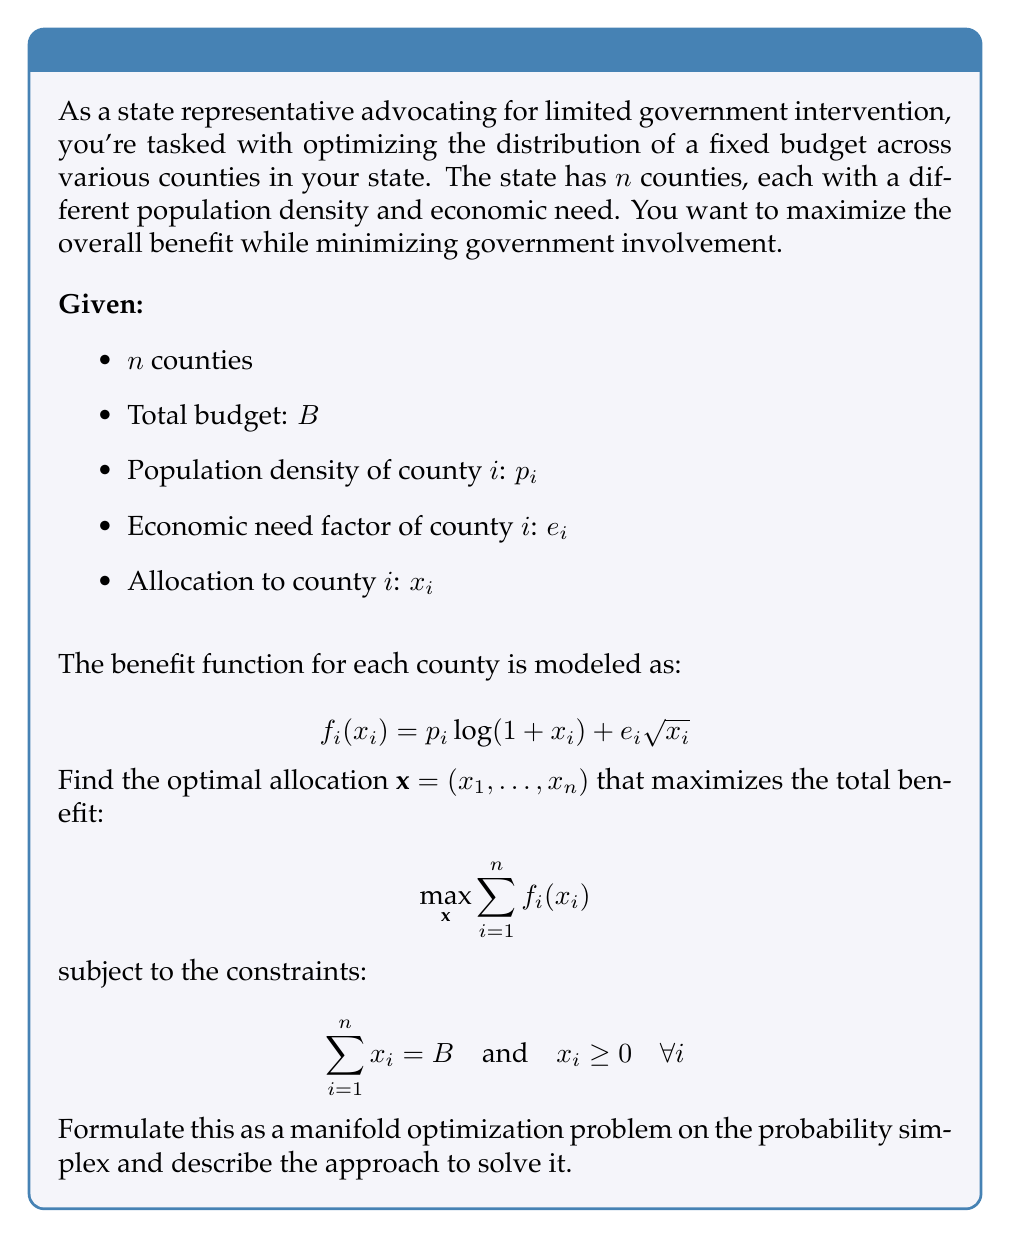Teach me how to tackle this problem. To solve this problem using manifold optimization, we can follow these steps:

1) First, we recognize that the constraint $\sum_{i=1}^n x_i = B$ with $x_i \geq 0$ defines a scaled probability simplex. We can transform our variables to work on the standard probability simplex by setting $y_i = x_i / B$. This gives us:

   $$ \max_{\mathbf{y}} \sum_{i=1}^n p_i \log(1 + By_i) + e_i \sqrt{By_i} $$
   
   subject to $\sum_{i=1}^n y_i = 1$ and $y_i \geq 0$.

2) The standard probability simplex is a manifold, specifically a $(n-1)$-dimensional manifold embedded in $\mathbb{R}^n$.

3) We can use the Riemannian gradient descent method on this manifold. The Riemannian gradient is the projection of the Euclidean gradient onto the tangent space of the manifold.

4) The Euclidean gradient for each $y_i$ is:

   $$ \frac{\partial f}{\partial y_i} = \frac{Bp_i}{1 + By_i} + \frac{Be_i}{2\sqrt{By_i}} $$

5) The projection onto the tangent space of the probability simplex is given by:

   $$ \text{Proj}_T(g) = g - (\mathbf{1}^T g)\mathbf{1} $$

   where $g$ is the Euclidean gradient and $\mathbf{1}$ is the vector of all ones.

6) The Riemannian gradient descent update step is:

   $$ \mathbf{y}^{(k+1)} = \text{Retr}_{\mathbf{y}^{(k)}}(-\alpha \text{Proj}_T(g)) $$

   where $\alpha$ is the step size and Retr is the retraction operation that maps a point in the tangent space back to the manifold.

7) For the probability simplex, a simple retraction is the projection onto the simplex, which can be done efficiently using algorithms like the one proposed by Wang and Carreira-Perpinán (2013).

8) We iterate this process until convergence, which gives us the optimal $\mathbf{y}^*$. We can then recover the original allocation by $\mathbf{x}^* = B\mathbf{y}^*$.

This approach allows us to solve the problem while respecting the budget constraint and non-negativity of allocations, aligning with the principle of limited government intervention by efficiently distributing a fixed budget.
Answer: The optimal allocation can be found by solving the manifold optimization problem on the probability simplex using Riemannian gradient descent. The steps involve:

1) Transform the problem to the standard probability simplex: $y_i = x_i / B$
2) Compute the Euclidean gradient: $\frac{\partial f}{\partial y_i} = \frac{Bp_i}{1 + By_i} + \frac{Be_i}{2\sqrt{By_i}}$
3) Project the gradient onto the tangent space of the simplex
4) Perform Riemannian gradient descent with appropriate retraction
5) Iterate until convergence to find $\mathbf{y}^*$
6) Recover the optimal allocation: $\mathbf{x}^* = B\mathbf{y}^*$

The exact numerical solution depends on the specific values of $n$, $B$, $p_i$, and $e_i$ for each county. 